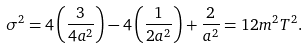Convert formula to latex. <formula><loc_0><loc_0><loc_500><loc_500>\sigma ^ { 2 } = 4 \left ( \frac { 3 } { 4 a ^ { 2 } } \right ) - 4 \left ( \frac { 1 } { 2 a ^ { 2 } } \right ) + \frac { 2 } { a ^ { 2 } } = 1 2 m ^ { 2 } T ^ { 2 } .</formula> 